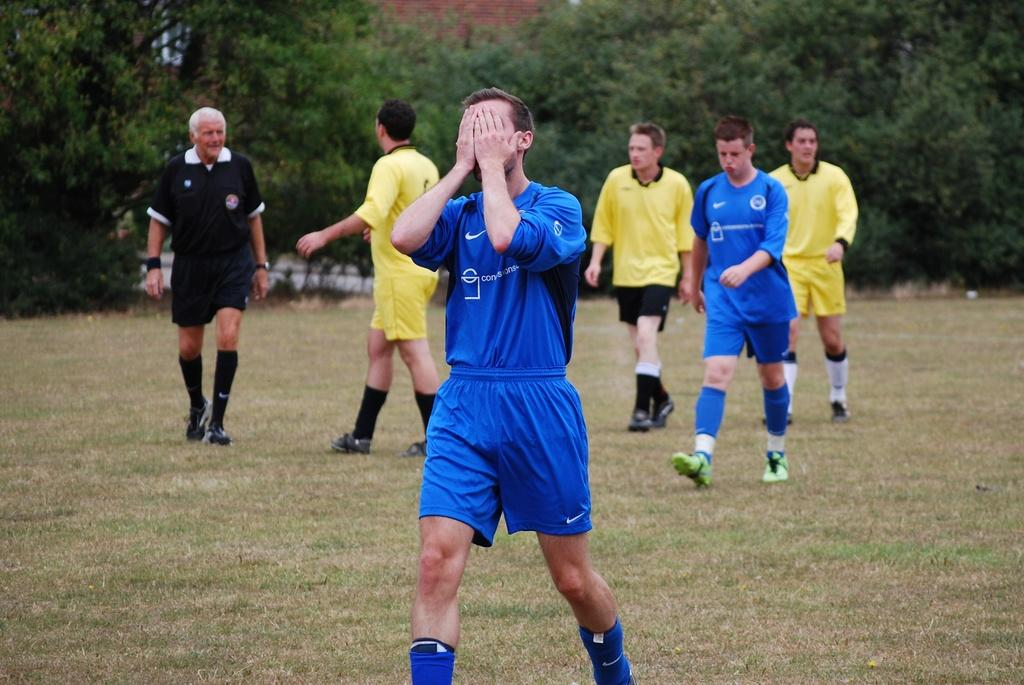How many people are present in the image? There are a few people in the image. What type of vegetation can be seen in the image? There are trees in the image. What is the ground surface like in the image? The ground with grass is visible in the image. What can be seen in the background of the image? There is a wall in the background of the image. What type of toys can be seen on the wall in the image? There are no toys visible on the wall in the image. 